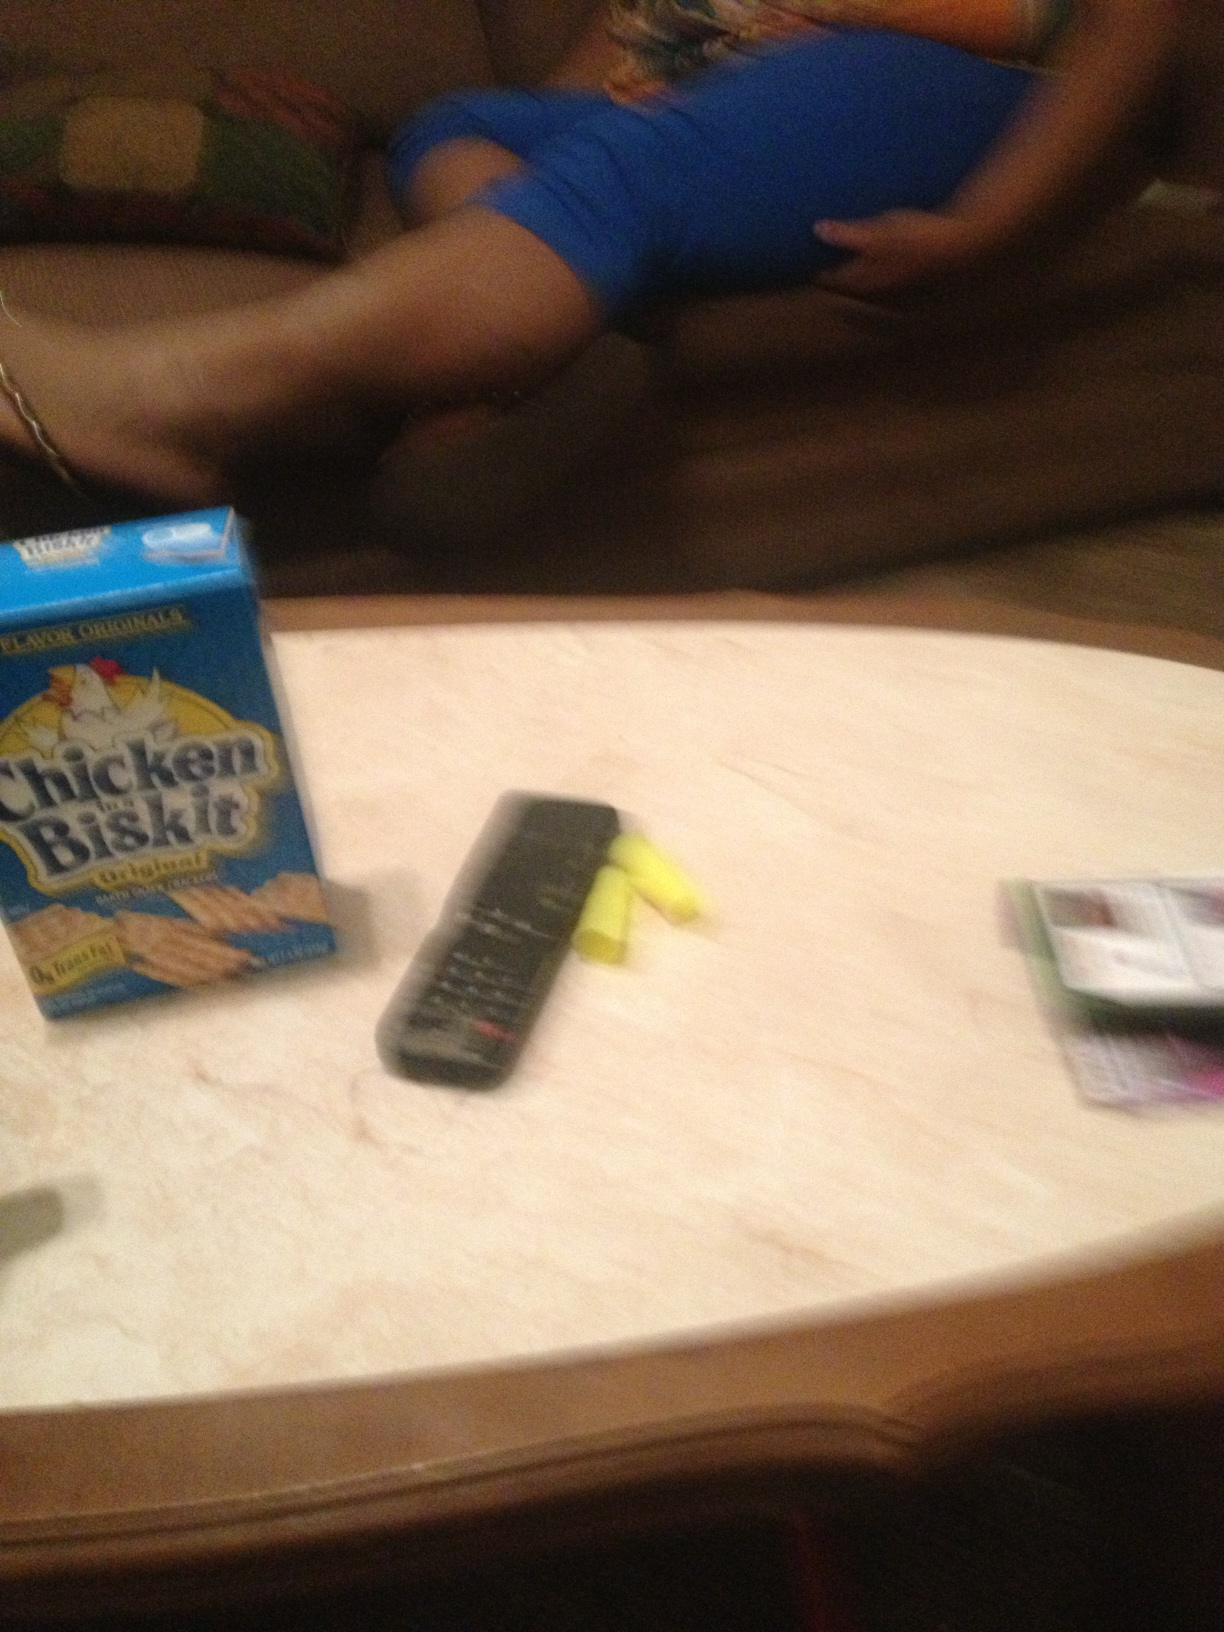What do you infer about the person based on the objects on the table? Judging by the items on the table, the person might enjoy savory snacks and possibly has been engaged in an activity that required highlighters or markers, like studying or organizing. The arrangement of items is casual, indicating a relaxed and informal environment. 